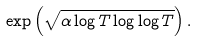Convert formula to latex. <formula><loc_0><loc_0><loc_500><loc_500>\exp \left ( \sqrt { \alpha \log T \log \log T } \right ) .</formula> 